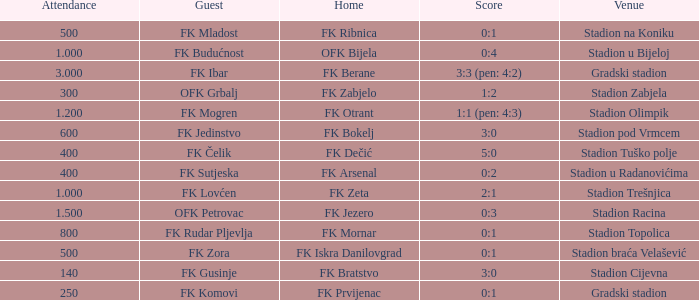What was the score for the game with FK Bratstvo as home team? 3:0. 